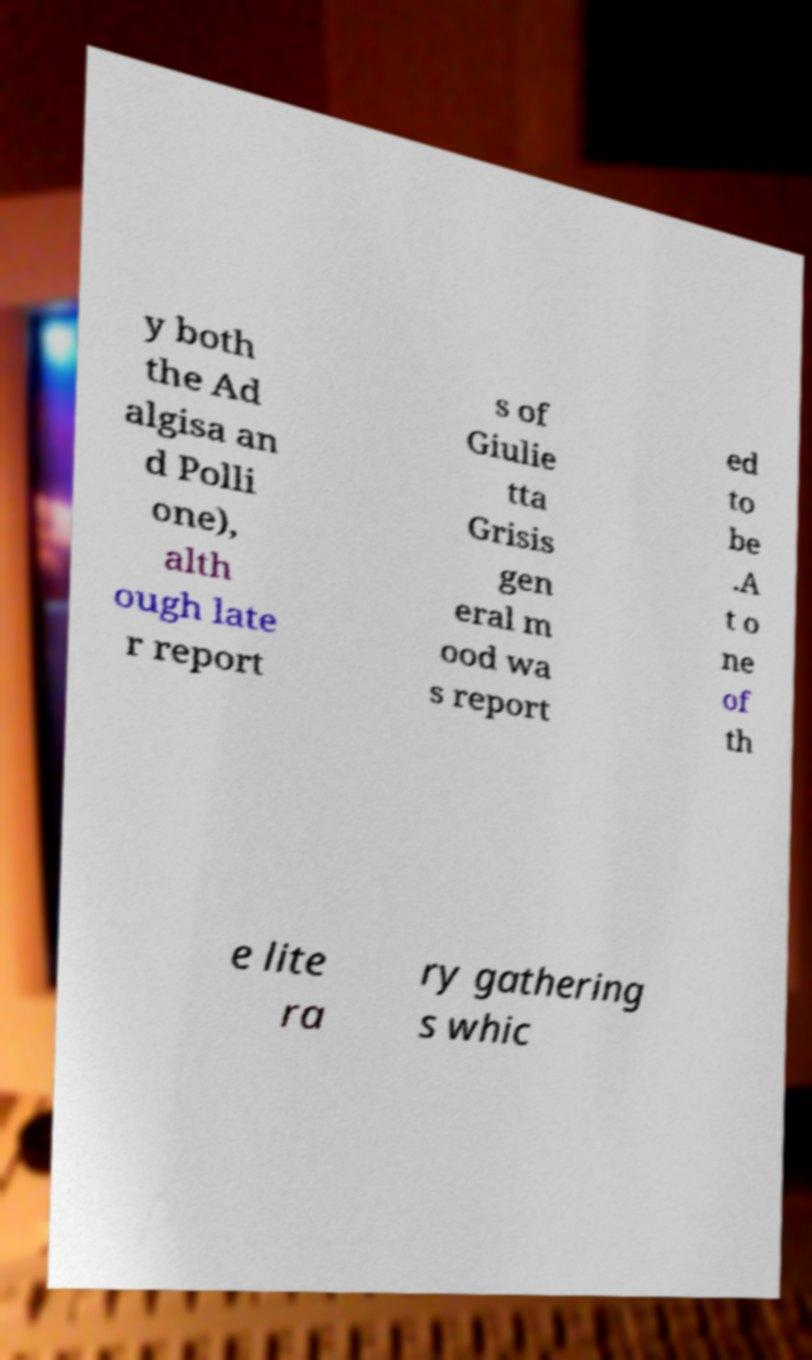I need the written content from this picture converted into text. Can you do that? y both the Ad algisa an d Polli one), alth ough late r report s of Giulie tta Grisis gen eral m ood wa s report ed to be .A t o ne of th e lite ra ry gathering s whic 